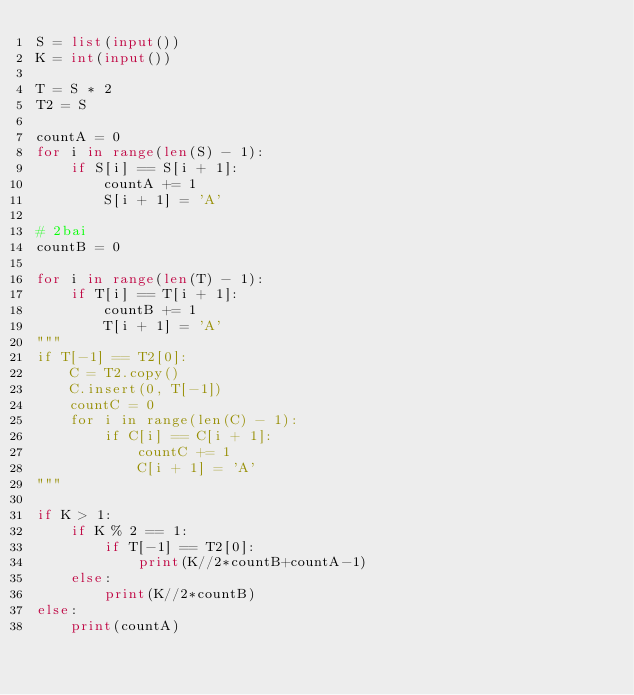<code> <loc_0><loc_0><loc_500><loc_500><_Python_>S = list(input())
K = int(input())

T = S * 2
T2 = S

countA = 0
for i in range(len(S) - 1):
    if S[i] == S[i + 1]:
        countA += 1
        S[i + 1] = 'A'

# 2bai
countB = 0

for i in range(len(T) - 1):
    if T[i] == T[i + 1]:
        countB += 1
        T[i + 1] = 'A'
"""
if T[-1] == T2[0]:
    C = T2.copy()
    C.insert(0, T[-1])
    countC = 0
    for i in range(len(C) - 1):
        if C[i] == C[i + 1]:
            countC += 1
            C[i + 1] = 'A'
"""

if K > 1:
    if K % 2 == 1:
        if T[-1] == T2[0]:
            print(K//2*countB+countA-1)
    else:
        print(K//2*countB)
else:
    print(countA)</code> 